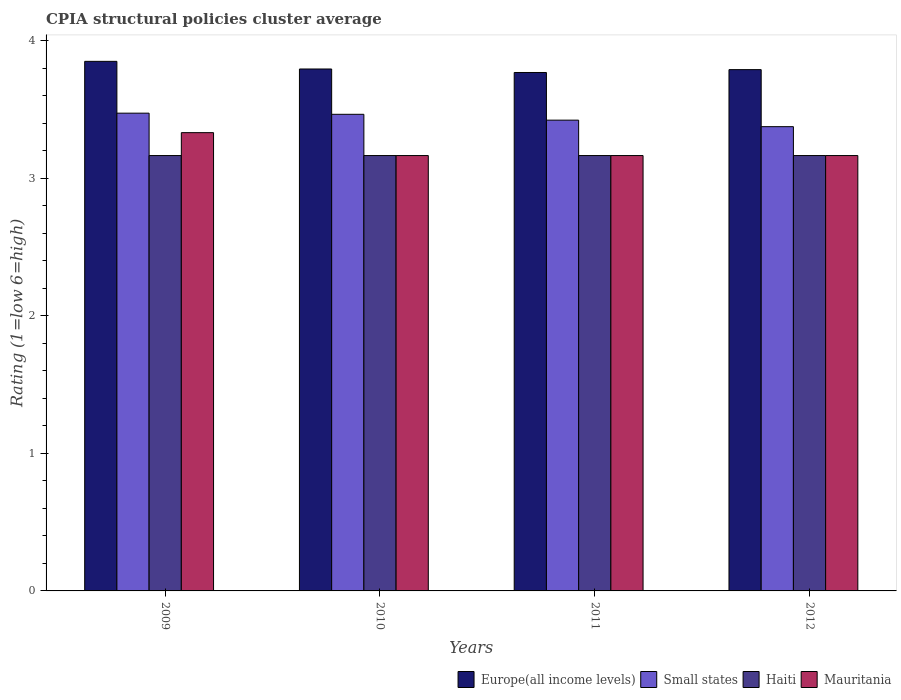Are the number of bars per tick equal to the number of legend labels?
Provide a succinct answer. Yes. Are the number of bars on each tick of the X-axis equal?
Your answer should be very brief. Yes. How many bars are there on the 1st tick from the right?
Make the answer very short. 4. In how many cases, is the number of bars for a given year not equal to the number of legend labels?
Ensure brevity in your answer.  0. What is the CPIA rating in Small states in 2010?
Offer a very short reply. 3.47. Across all years, what is the maximum CPIA rating in Small states?
Provide a short and direct response. 3.48. Across all years, what is the minimum CPIA rating in Europe(all income levels)?
Offer a terse response. 3.77. In which year was the CPIA rating in Mauritania maximum?
Your answer should be very brief. 2009. What is the total CPIA rating in Small states in the graph?
Offer a terse response. 13.74. What is the difference between the CPIA rating in Mauritania in 2009 and that in 2010?
Your answer should be very brief. 0.17. What is the difference between the CPIA rating in Haiti in 2010 and the CPIA rating in Small states in 2009?
Your answer should be very brief. -0.31. What is the average CPIA rating in Haiti per year?
Your response must be concise. 3.17. In the year 2009, what is the difference between the CPIA rating in Europe(all income levels) and CPIA rating in Small states?
Make the answer very short. 0.38. In how many years, is the CPIA rating in Europe(all income levels) greater than 0.2?
Give a very brief answer. 4. What is the ratio of the CPIA rating in Small states in 2010 to that in 2012?
Your response must be concise. 1.03. What is the difference between the highest and the second highest CPIA rating in Europe(all income levels)?
Your response must be concise. 0.06. What is the difference between the highest and the lowest CPIA rating in Small states?
Your answer should be compact. 0.1. Is it the case that in every year, the sum of the CPIA rating in Small states and CPIA rating in Europe(all income levels) is greater than the sum of CPIA rating in Haiti and CPIA rating in Mauritania?
Your response must be concise. Yes. What does the 3rd bar from the left in 2009 represents?
Ensure brevity in your answer.  Haiti. What does the 3rd bar from the right in 2010 represents?
Your answer should be very brief. Small states. Is it the case that in every year, the sum of the CPIA rating in Haiti and CPIA rating in Europe(all income levels) is greater than the CPIA rating in Small states?
Offer a very short reply. Yes. How many bars are there?
Provide a short and direct response. 16. Are all the bars in the graph horizontal?
Your response must be concise. No. What is the difference between two consecutive major ticks on the Y-axis?
Your answer should be compact. 1. Are the values on the major ticks of Y-axis written in scientific E-notation?
Ensure brevity in your answer.  No. Where does the legend appear in the graph?
Your response must be concise. Bottom right. How are the legend labels stacked?
Provide a succinct answer. Horizontal. What is the title of the graph?
Your answer should be very brief. CPIA structural policies cluster average. What is the label or title of the X-axis?
Give a very brief answer. Years. What is the label or title of the Y-axis?
Your answer should be very brief. Rating (1=low 6=high). What is the Rating (1=low 6=high) of Europe(all income levels) in 2009?
Your response must be concise. 3.85. What is the Rating (1=low 6=high) of Small states in 2009?
Ensure brevity in your answer.  3.48. What is the Rating (1=low 6=high) in Haiti in 2009?
Offer a very short reply. 3.17. What is the Rating (1=low 6=high) in Mauritania in 2009?
Offer a very short reply. 3.33. What is the Rating (1=low 6=high) in Europe(all income levels) in 2010?
Your response must be concise. 3.8. What is the Rating (1=low 6=high) of Small states in 2010?
Keep it short and to the point. 3.47. What is the Rating (1=low 6=high) of Haiti in 2010?
Ensure brevity in your answer.  3.17. What is the Rating (1=low 6=high) in Mauritania in 2010?
Your answer should be compact. 3.17. What is the Rating (1=low 6=high) of Europe(all income levels) in 2011?
Your answer should be compact. 3.77. What is the Rating (1=low 6=high) in Small states in 2011?
Provide a succinct answer. 3.42. What is the Rating (1=low 6=high) in Haiti in 2011?
Offer a terse response. 3.17. What is the Rating (1=low 6=high) of Mauritania in 2011?
Your answer should be compact. 3.17. What is the Rating (1=low 6=high) in Europe(all income levels) in 2012?
Make the answer very short. 3.79. What is the Rating (1=low 6=high) in Small states in 2012?
Offer a very short reply. 3.38. What is the Rating (1=low 6=high) of Haiti in 2012?
Keep it short and to the point. 3.17. What is the Rating (1=low 6=high) of Mauritania in 2012?
Offer a terse response. 3.17. Across all years, what is the maximum Rating (1=low 6=high) of Europe(all income levels)?
Give a very brief answer. 3.85. Across all years, what is the maximum Rating (1=low 6=high) in Small states?
Your answer should be very brief. 3.48. Across all years, what is the maximum Rating (1=low 6=high) in Haiti?
Provide a succinct answer. 3.17. Across all years, what is the maximum Rating (1=low 6=high) of Mauritania?
Provide a succinct answer. 3.33. Across all years, what is the minimum Rating (1=low 6=high) of Europe(all income levels)?
Provide a short and direct response. 3.77. Across all years, what is the minimum Rating (1=low 6=high) of Small states?
Provide a short and direct response. 3.38. Across all years, what is the minimum Rating (1=low 6=high) in Haiti?
Keep it short and to the point. 3.17. Across all years, what is the minimum Rating (1=low 6=high) of Mauritania?
Provide a short and direct response. 3.17. What is the total Rating (1=low 6=high) of Europe(all income levels) in the graph?
Offer a very short reply. 15.21. What is the total Rating (1=low 6=high) in Small states in the graph?
Give a very brief answer. 13.74. What is the total Rating (1=low 6=high) of Haiti in the graph?
Your answer should be very brief. 12.67. What is the total Rating (1=low 6=high) in Mauritania in the graph?
Ensure brevity in your answer.  12.83. What is the difference between the Rating (1=low 6=high) in Europe(all income levels) in 2009 and that in 2010?
Ensure brevity in your answer.  0.06. What is the difference between the Rating (1=low 6=high) in Small states in 2009 and that in 2010?
Provide a short and direct response. 0.01. What is the difference between the Rating (1=low 6=high) of Haiti in 2009 and that in 2010?
Give a very brief answer. 0. What is the difference between the Rating (1=low 6=high) in Mauritania in 2009 and that in 2010?
Provide a short and direct response. 0.17. What is the difference between the Rating (1=low 6=high) in Europe(all income levels) in 2009 and that in 2011?
Give a very brief answer. 0.08. What is the difference between the Rating (1=low 6=high) in Small states in 2009 and that in 2011?
Keep it short and to the point. 0.05. What is the difference between the Rating (1=low 6=high) of Haiti in 2009 and that in 2011?
Make the answer very short. 0. What is the difference between the Rating (1=low 6=high) of Mauritania in 2009 and that in 2011?
Make the answer very short. 0.17. What is the difference between the Rating (1=low 6=high) in Europe(all income levels) in 2009 and that in 2012?
Offer a very short reply. 0.06. What is the difference between the Rating (1=low 6=high) of Small states in 2009 and that in 2012?
Give a very brief answer. 0.1. What is the difference between the Rating (1=low 6=high) in Europe(all income levels) in 2010 and that in 2011?
Provide a succinct answer. 0.03. What is the difference between the Rating (1=low 6=high) of Small states in 2010 and that in 2011?
Provide a succinct answer. 0.04. What is the difference between the Rating (1=low 6=high) of Haiti in 2010 and that in 2011?
Offer a very short reply. 0. What is the difference between the Rating (1=low 6=high) of Mauritania in 2010 and that in 2011?
Ensure brevity in your answer.  0. What is the difference between the Rating (1=low 6=high) of Europe(all income levels) in 2010 and that in 2012?
Provide a short and direct response. 0. What is the difference between the Rating (1=low 6=high) of Small states in 2010 and that in 2012?
Keep it short and to the point. 0.09. What is the difference between the Rating (1=low 6=high) in Mauritania in 2010 and that in 2012?
Make the answer very short. 0. What is the difference between the Rating (1=low 6=high) in Europe(all income levels) in 2011 and that in 2012?
Offer a very short reply. -0.02. What is the difference between the Rating (1=low 6=high) in Small states in 2011 and that in 2012?
Make the answer very short. 0.05. What is the difference between the Rating (1=low 6=high) in Europe(all income levels) in 2009 and the Rating (1=low 6=high) in Small states in 2010?
Offer a very short reply. 0.39. What is the difference between the Rating (1=low 6=high) in Europe(all income levels) in 2009 and the Rating (1=low 6=high) in Haiti in 2010?
Offer a terse response. 0.69. What is the difference between the Rating (1=low 6=high) in Europe(all income levels) in 2009 and the Rating (1=low 6=high) in Mauritania in 2010?
Provide a short and direct response. 0.69. What is the difference between the Rating (1=low 6=high) in Small states in 2009 and the Rating (1=low 6=high) in Haiti in 2010?
Provide a succinct answer. 0.31. What is the difference between the Rating (1=low 6=high) in Small states in 2009 and the Rating (1=low 6=high) in Mauritania in 2010?
Make the answer very short. 0.31. What is the difference between the Rating (1=low 6=high) of Haiti in 2009 and the Rating (1=low 6=high) of Mauritania in 2010?
Offer a very short reply. 0. What is the difference between the Rating (1=low 6=high) in Europe(all income levels) in 2009 and the Rating (1=low 6=high) in Small states in 2011?
Offer a very short reply. 0.43. What is the difference between the Rating (1=low 6=high) in Europe(all income levels) in 2009 and the Rating (1=low 6=high) in Haiti in 2011?
Your response must be concise. 0.69. What is the difference between the Rating (1=low 6=high) in Europe(all income levels) in 2009 and the Rating (1=low 6=high) in Mauritania in 2011?
Give a very brief answer. 0.69. What is the difference between the Rating (1=low 6=high) in Small states in 2009 and the Rating (1=low 6=high) in Haiti in 2011?
Provide a short and direct response. 0.31. What is the difference between the Rating (1=low 6=high) in Small states in 2009 and the Rating (1=low 6=high) in Mauritania in 2011?
Keep it short and to the point. 0.31. What is the difference between the Rating (1=low 6=high) in Europe(all income levels) in 2009 and the Rating (1=low 6=high) in Small states in 2012?
Your response must be concise. 0.47. What is the difference between the Rating (1=low 6=high) of Europe(all income levels) in 2009 and the Rating (1=low 6=high) of Haiti in 2012?
Offer a terse response. 0.69. What is the difference between the Rating (1=low 6=high) of Europe(all income levels) in 2009 and the Rating (1=low 6=high) of Mauritania in 2012?
Your answer should be compact. 0.69. What is the difference between the Rating (1=low 6=high) in Small states in 2009 and the Rating (1=low 6=high) in Haiti in 2012?
Your response must be concise. 0.31. What is the difference between the Rating (1=low 6=high) in Small states in 2009 and the Rating (1=low 6=high) in Mauritania in 2012?
Offer a terse response. 0.31. What is the difference between the Rating (1=low 6=high) in Europe(all income levels) in 2010 and the Rating (1=low 6=high) in Small states in 2011?
Your answer should be compact. 0.37. What is the difference between the Rating (1=low 6=high) in Europe(all income levels) in 2010 and the Rating (1=low 6=high) in Haiti in 2011?
Offer a very short reply. 0.63. What is the difference between the Rating (1=low 6=high) of Europe(all income levels) in 2010 and the Rating (1=low 6=high) of Mauritania in 2011?
Your answer should be very brief. 0.63. What is the difference between the Rating (1=low 6=high) in Small states in 2010 and the Rating (1=low 6=high) in Mauritania in 2011?
Provide a succinct answer. 0.3. What is the difference between the Rating (1=low 6=high) in Haiti in 2010 and the Rating (1=low 6=high) in Mauritania in 2011?
Provide a short and direct response. 0. What is the difference between the Rating (1=low 6=high) in Europe(all income levels) in 2010 and the Rating (1=low 6=high) in Small states in 2012?
Ensure brevity in your answer.  0.42. What is the difference between the Rating (1=low 6=high) in Europe(all income levels) in 2010 and the Rating (1=low 6=high) in Haiti in 2012?
Your answer should be very brief. 0.63. What is the difference between the Rating (1=low 6=high) of Europe(all income levels) in 2010 and the Rating (1=low 6=high) of Mauritania in 2012?
Give a very brief answer. 0.63. What is the difference between the Rating (1=low 6=high) in Small states in 2010 and the Rating (1=low 6=high) in Haiti in 2012?
Your response must be concise. 0.3. What is the difference between the Rating (1=low 6=high) in Small states in 2010 and the Rating (1=low 6=high) in Mauritania in 2012?
Your response must be concise. 0.3. What is the difference between the Rating (1=low 6=high) in Europe(all income levels) in 2011 and the Rating (1=low 6=high) in Small states in 2012?
Give a very brief answer. 0.39. What is the difference between the Rating (1=low 6=high) of Europe(all income levels) in 2011 and the Rating (1=low 6=high) of Haiti in 2012?
Your answer should be very brief. 0.6. What is the difference between the Rating (1=low 6=high) of Europe(all income levels) in 2011 and the Rating (1=low 6=high) of Mauritania in 2012?
Make the answer very short. 0.6. What is the difference between the Rating (1=low 6=high) in Small states in 2011 and the Rating (1=low 6=high) in Haiti in 2012?
Keep it short and to the point. 0.26. What is the difference between the Rating (1=low 6=high) in Small states in 2011 and the Rating (1=low 6=high) in Mauritania in 2012?
Ensure brevity in your answer.  0.26. What is the average Rating (1=low 6=high) of Europe(all income levels) per year?
Keep it short and to the point. 3.8. What is the average Rating (1=low 6=high) in Small states per year?
Give a very brief answer. 3.44. What is the average Rating (1=low 6=high) in Haiti per year?
Offer a very short reply. 3.17. What is the average Rating (1=low 6=high) in Mauritania per year?
Your answer should be very brief. 3.21. In the year 2009, what is the difference between the Rating (1=low 6=high) in Europe(all income levels) and Rating (1=low 6=high) in Small states?
Ensure brevity in your answer.  0.38. In the year 2009, what is the difference between the Rating (1=low 6=high) in Europe(all income levels) and Rating (1=low 6=high) in Haiti?
Make the answer very short. 0.69. In the year 2009, what is the difference between the Rating (1=low 6=high) in Europe(all income levels) and Rating (1=low 6=high) in Mauritania?
Your response must be concise. 0.52. In the year 2009, what is the difference between the Rating (1=low 6=high) of Small states and Rating (1=low 6=high) of Haiti?
Ensure brevity in your answer.  0.31. In the year 2009, what is the difference between the Rating (1=low 6=high) of Small states and Rating (1=low 6=high) of Mauritania?
Provide a succinct answer. 0.14. In the year 2009, what is the difference between the Rating (1=low 6=high) in Haiti and Rating (1=low 6=high) in Mauritania?
Your answer should be compact. -0.17. In the year 2010, what is the difference between the Rating (1=low 6=high) of Europe(all income levels) and Rating (1=low 6=high) of Small states?
Offer a terse response. 0.33. In the year 2010, what is the difference between the Rating (1=low 6=high) in Europe(all income levels) and Rating (1=low 6=high) in Haiti?
Offer a very short reply. 0.63. In the year 2010, what is the difference between the Rating (1=low 6=high) of Europe(all income levels) and Rating (1=low 6=high) of Mauritania?
Offer a terse response. 0.63. In the year 2010, what is the difference between the Rating (1=low 6=high) of Small states and Rating (1=low 6=high) of Haiti?
Provide a succinct answer. 0.3. In the year 2010, what is the difference between the Rating (1=low 6=high) in Haiti and Rating (1=low 6=high) in Mauritania?
Your answer should be compact. 0. In the year 2011, what is the difference between the Rating (1=low 6=high) in Europe(all income levels) and Rating (1=low 6=high) in Small states?
Ensure brevity in your answer.  0.35. In the year 2011, what is the difference between the Rating (1=low 6=high) of Europe(all income levels) and Rating (1=low 6=high) of Haiti?
Offer a terse response. 0.6. In the year 2011, what is the difference between the Rating (1=low 6=high) in Europe(all income levels) and Rating (1=low 6=high) in Mauritania?
Offer a very short reply. 0.6. In the year 2011, what is the difference between the Rating (1=low 6=high) in Small states and Rating (1=low 6=high) in Haiti?
Make the answer very short. 0.26. In the year 2011, what is the difference between the Rating (1=low 6=high) in Small states and Rating (1=low 6=high) in Mauritania?
Offer a terse response. 0.26. In the year 2012, what is the difference between the Rating (1=low 6=high) of Europe(all income levels) and Rating (1=low 6=high) of Small states?
Give a very brief answer. 0.41. In the year 2012, what is the difference between the Rating (1=low 6=high) of Small states and Rating (1=low 6=high) of Haiti?
Make the answer very short. 0.21. In the year 2012, what is the difference between the Rating (1=low 6=high) in Small states and Rating (1=low 6=high) in Mauritania?
Provide a succinct answer. 0.21. What is the ratio of the Rating (1=low 6=high) of Europe(all income levels) in 2009 to that in 2010?
Offer a terse response. 1.01. What is the ratio of the Rating (1=low 6=high) in Small states in 2009 to that in 2010?
Provide a succinct answer. 1. What is the ratio of the Rating (1=low 6=high) in Haiti in 2009 to that in 2010?
Offer a terse response. 1. What is the ratio of the Rating (1=low 6=high) of Mauritania in 2009 to that in 2010?
Provide a succinct answer. 1.05. What is the ratio of the Rating (1=low 6=high) of Europe(all income levels) in 2009 to that in 2011?
Offer a terse response. 1.02. What is the ratio of the Rating (1=low 6=high) in Small states in 2009 to that in 2011?
Provide a short and direct response. 1.01. What is the ratio of the Rating (1=low 6=high) of Mauritania in 2009 to that in 2011?
Ensure brevity in your answer.  1.05. What is the ratio of the Rating (1=low 6=high) in Europe(all income levels) in 2009 to that in 2012?
Provide a short and direct response. 1.02. What is the ratio of the Rating (1=low 6=high) in Small states in 2009 to that in 2012?
Make the answer very short. 1.03. What is the ratio of the Rating (1=low 6=high) of Haiti in 2009 to that in 2012?
Make the answer very short. 1. What is the ratio of the Rating (1=low 6=high) in Mauritania in 2009 to that in 2012?
Provide a short and direct response. 1.05. What is the ratio of the Rating (1=low 6=high) in Europe(all income levels) in 2010 to that in 2011?
Offer a very short reply. 1.01. What is the ratio of the Rating (1=low 6=high) in Small states in 2010 to that in 2011?
Give a very brief answer. 1.01. What is the ratio of the Rating (1=low 6=high) in Small states in 2010 to that in 2012?
Your answer should be compact. 1.03. What is the ratio of the Rating (1=low 6=high) of Mauritania in 2010 to that in 2012?
Provide a short and direct response. 1. What is the ratio of the Rating (1=low 6=high) of Europe(all income levels) in 2011 to that in 2012?
Your answer should be compact. 0.99. What is the ratio of the Rating (1=low 6=high) in Small states in 2011 to that in 2012?
Offer a very short reply. 1.01. What is the ratio of the Rating (1=low 6=high) of Haiti in 2011 to that in 2012?
Give a very brief answer. 1. What is the difference between the highest and the second highest Rating (1=low 6=high) in Europe(all income levels)?
Give a very brief answer. 0.06. What is the difference between the highest and the second highest Rating (1=low 6=high) in Small states?
Ensure brevity in your answer.  0.01. What is the difference between the highest and the second highest Rating (1=low 6=high) of Mauritania?
Make the answer very short. 0.17. What is the difference between the highest and the lowest Rating (1=low 6=high) in Europe(all income levels)?
Ensure brevity in your answer.  0.08. What is the difference between the highest and the lowest Rating (1=low 6=high) in Small states?
Keep it short and to the point. 0.1. What is the difference between the highest and the lowest Rating (1=low 6=high) of Mauritania?
Offer a very short reply. 0.17. 